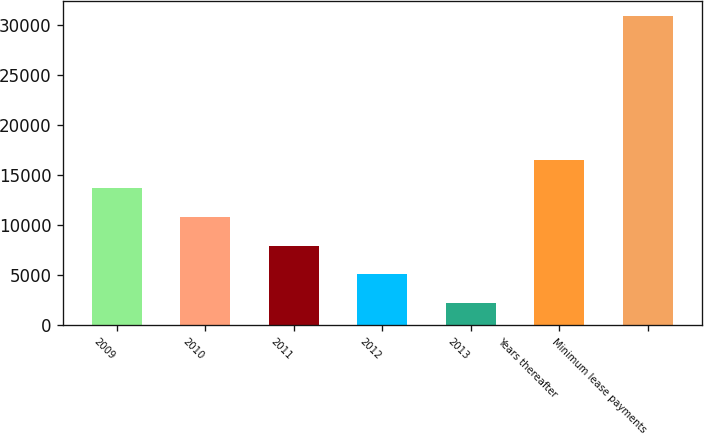Convert chart. <chart><loc_0><loc_0><loc_500><loc_500><bar_chart><fcel>2009<fcel>2010<fcel>2011<fcel>2012<fcel>2013<fcel>Years thereafter<fcel>Minimum lease payments<nl><fcel>13677<fcel>10803<fcel>7929<fcel>5055<fcel>2181<fcel>16551<fcel>30921<nl></chart> 